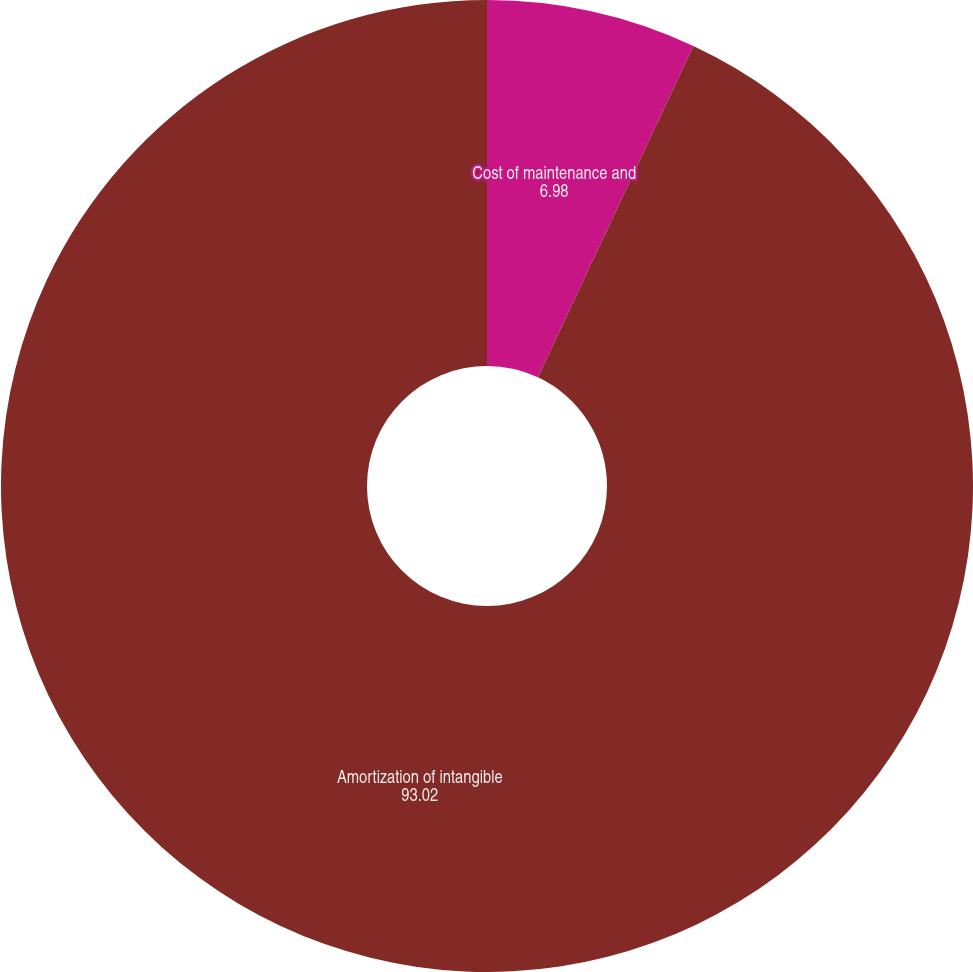Convert chart to OTSL. <chart><loc_0><loc_0><loc_500><loc_500><pie_chart><fcel>Cost of maintenance and<fcel>Amortization of intangible<nl><fcel>6.98%<fcel>93.02%<nl></chart> 